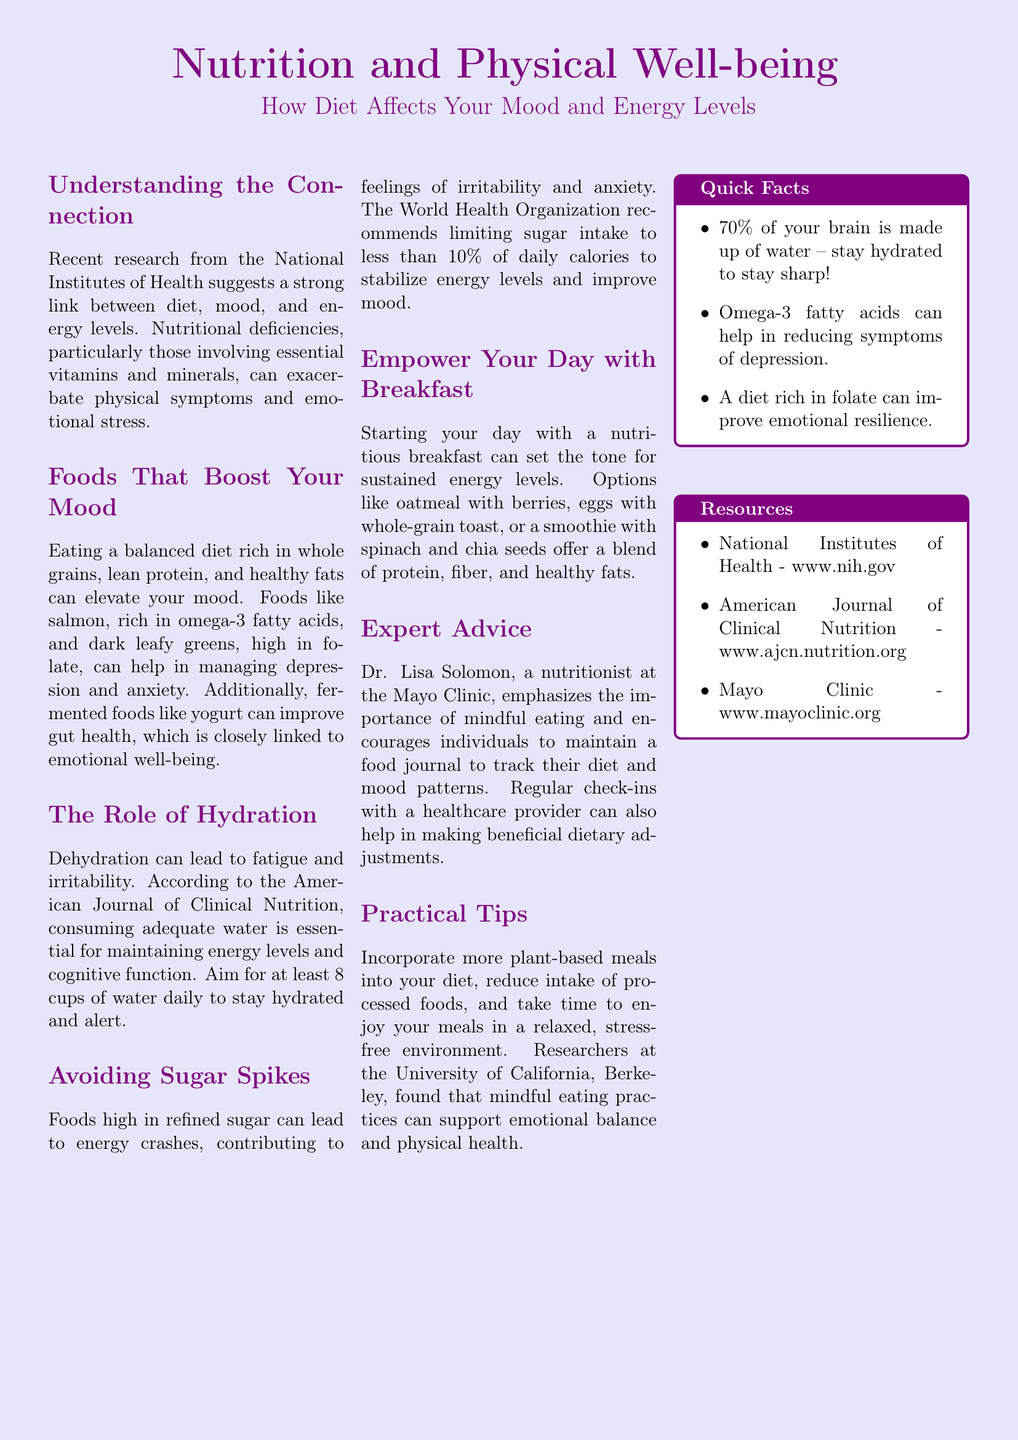What is the main topic of the document? The document discusses the relationship between nutrition, physical well-being, mood, and energy levels.
Answer: Nutrition and Physical Well-being Which organization conducted research linking diet to mood and energy levels? The research mentioned in the document is from the National Institutes of Health.
Answer: National Institutes of Health What type of foods can elevate your mood? The document states that whole grains, lean protein, and healthy fats can elevate mood.
Answer: Whole grains, lean protein, healthy fats How many cups of water does the document recommend consuming daily? The document recommends aiming for at least 8 cups of water daily.
Answer: 8 cups What is one food that is rich in omega-3 fatty acids? The document lists salmon as a food rich in omega-3 fatty acids.
Answer: Salmon What impact do refined sugars have according to the document? Refined sugars lead to energy crashes, contributing to irritability and anxiety.
Answer: Energy crashes Who provides expert advice in the document? Dr. Lisa Solomon is the nutritionist mentioned for providing expert advice.
Answer: Dr. Lisa Solomon What practice does the University of California, Berkeley, suggest to support emotional balance? The document suggests incorporating mindful eating practices.
Answer: Mindful eating practices 